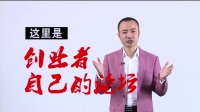Can you tell me about the style of clothing the man is wearing and what it might imply in this context? The man is dressed in a modish pink blazer paired with a white shirt, a choice that exudes both modernity and personal style. This sartorial decision might imply that he holds a position where personal branding is significant, such as a television personality, an influencer, or a professional in a creative industry. The color pink is often associated with approachability and creativity, which may be deliberate to appear more relatable and engaging to the audience he is addressing. 